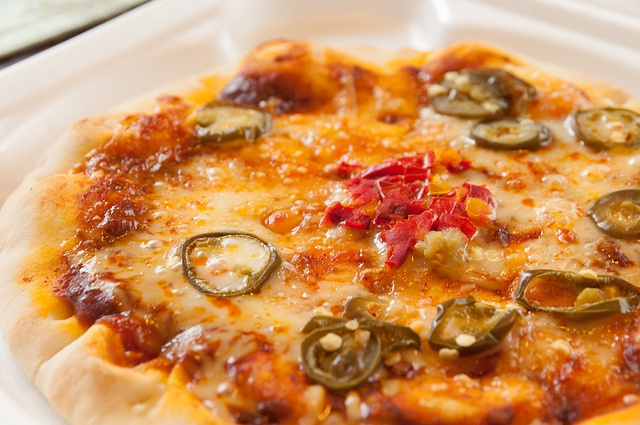Describe the objects in this image and their specific colors. I can see a pizza in lightgray, tan, red, brown, and orange tones in this image. 